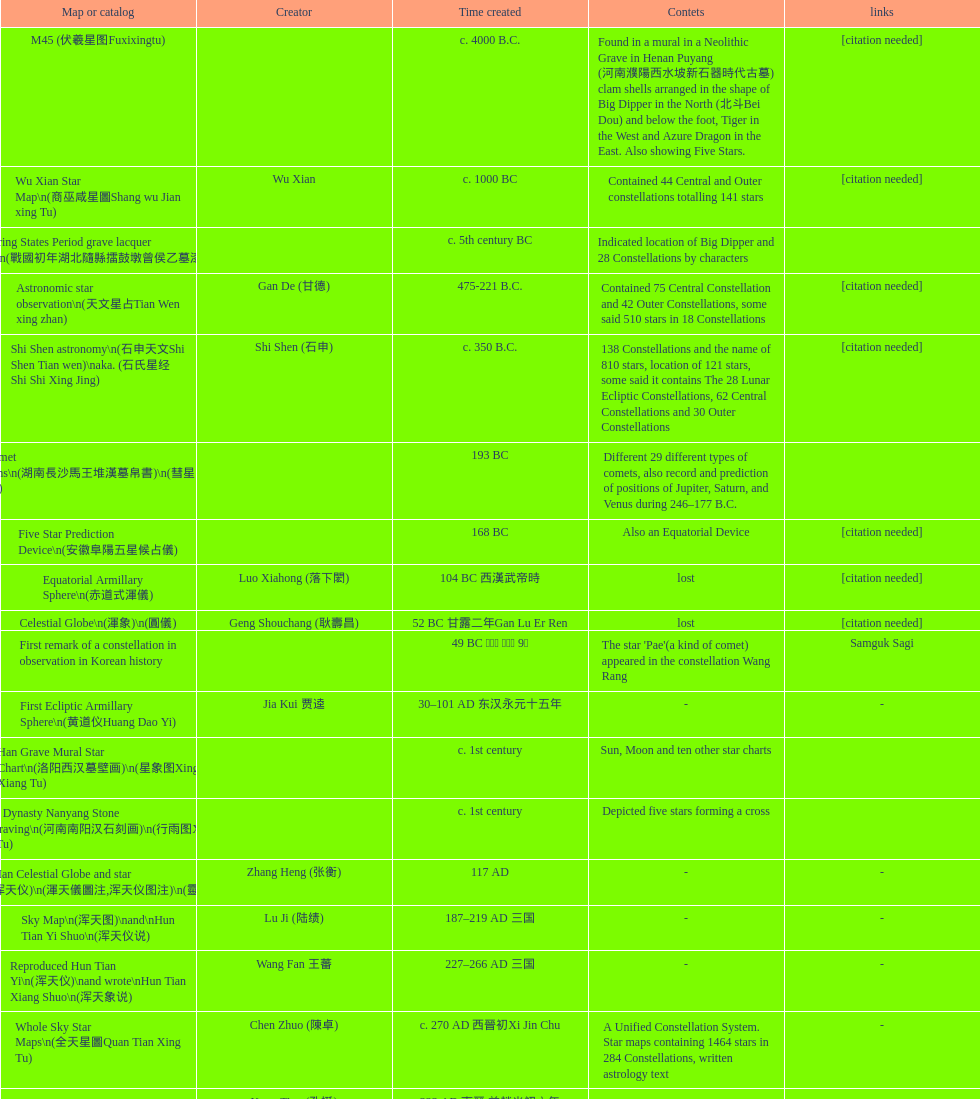What is the difference between the five star prediction device's date of creation and the han comet diagrams' date of creation? 25 years. 